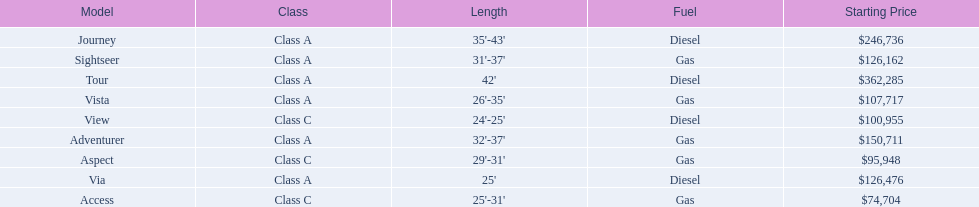What are all the class a models of the winnebago industries? Tour, Journey, Adventurer, Via, Sightseer, Vista. Of those class a models, which has the highest starting price? Tour. 